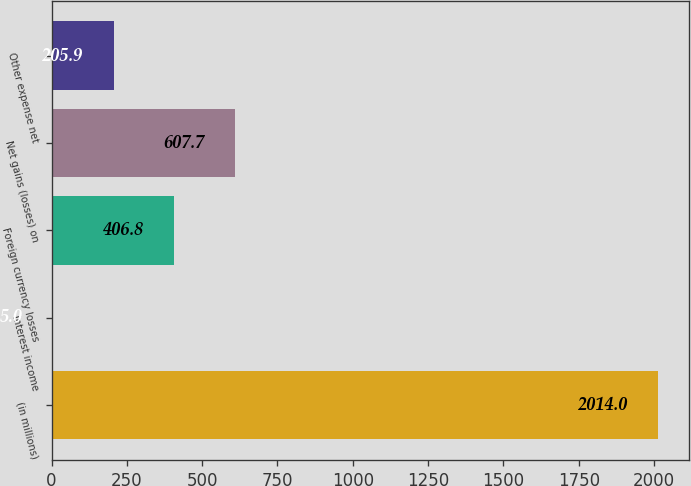Convert chart. <chart><loc_0><loc_0><loc_500><loc_500><bar_chart><fcel>(in millions)<fcel>Interest income<fcel>Foreign currency losses<fcel>Net gains (losses) on<fcel>Other expense net<nl><fcel>2014<fcel>5<fcel>406.8<fcel>607.7<fcel>205.9<nl></chart> 